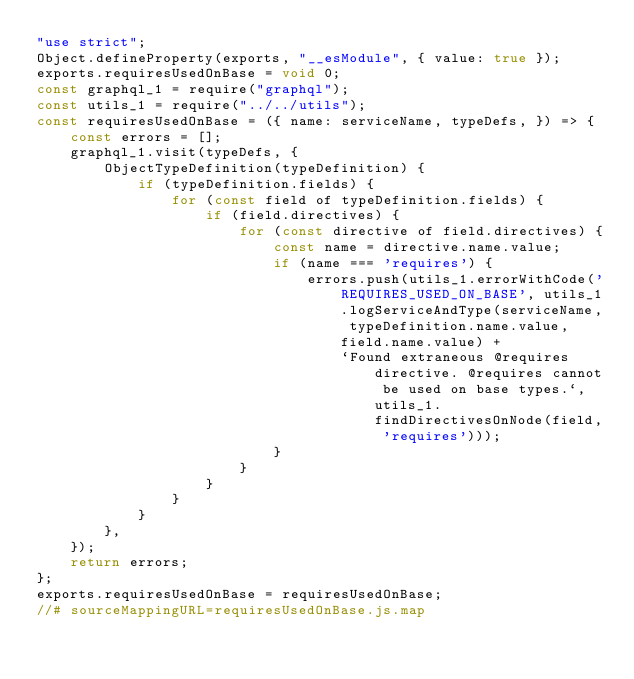Convert code to text. <code><loc_0><loc_0><loc_500><loc_500><_JavaScript_>"use strict";
Object.defineProperty(exports, "__esModule", { value: true });
exports.requiresUsedOnBase = void 0;
const graphql_1 = require("graphql");
const utils_1 = require("../../utils");
const requiresUsedOnBase = ({ name: serviceName, typeDefs, }) => {
    const errors = [];
    graphql_1.visit(typeDefs, {
        ObjectTypeDefinition(typeDefinition) {
            if (typeDefinition.fields) {
                for (const field of typeDefinition.fields) {
                    if (field.directives) {
                        for (const directive of field.directives) {
                            const name = directive.name.value;
                            if (name === 'requires') {
                                errors.push(utils_1.errorWithCode('REQUIRES_USED_ON_BASE', utils_1.logServiceAndType(serviceName, typeDefinition.name.value, field.name.value) +
                                    `Found extraneous @requires directive. @requires cannot be used on base types.`, utils_1.findDirectivesOnNode(field, 'requires')));
                            }
                        }
                    }
                }
            }
        },
    });
    return errors;
};
exports.requiresUsedOnBase = requiresUsedOnBase;
//# sourceMappingURL=requiresUsedOnBase.js.map</code> 